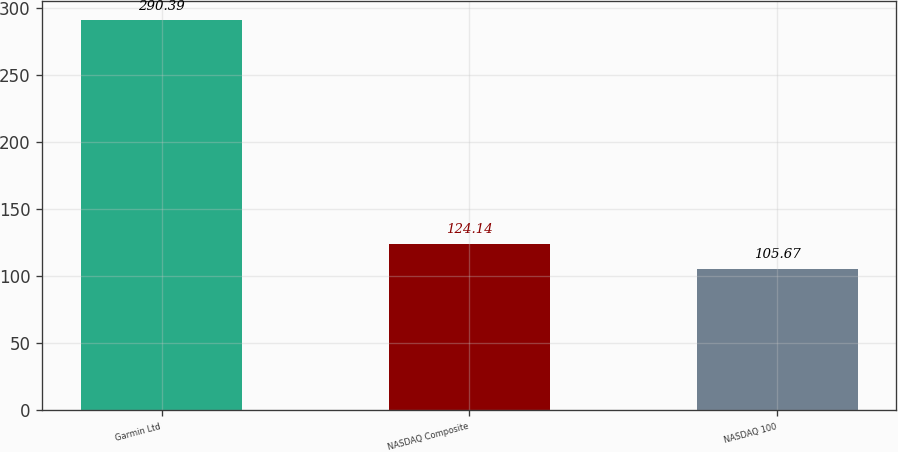<chart> <loc_0><loc_0><loc_500><loc_500><bar_chart><fcel>Garmin Ltd<fcel>NASDAQ Composite<fcel>NASDAQ 100<nl><fcel>290.39<fcel>124.14<fcel>105.67<nl></chart> 